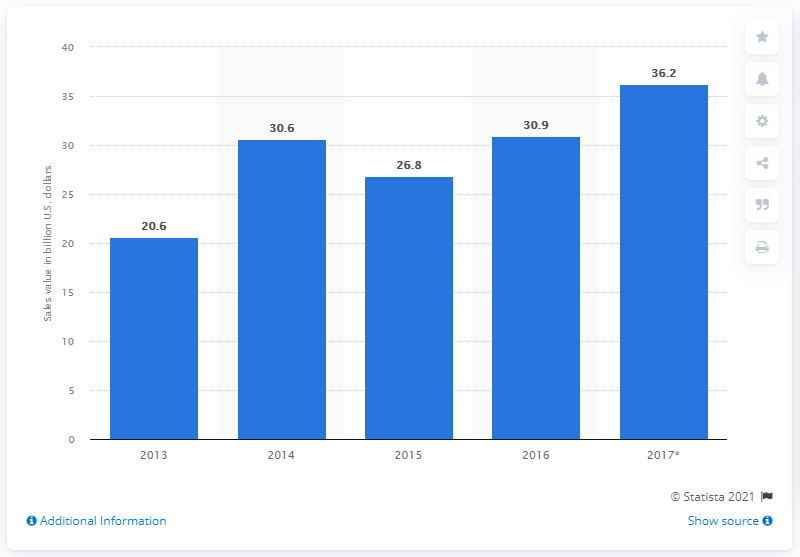Outline some significant characteristics in this image. The estimated revenue from smartphone sales in Latin America in 2017 was $36.2 billion. 